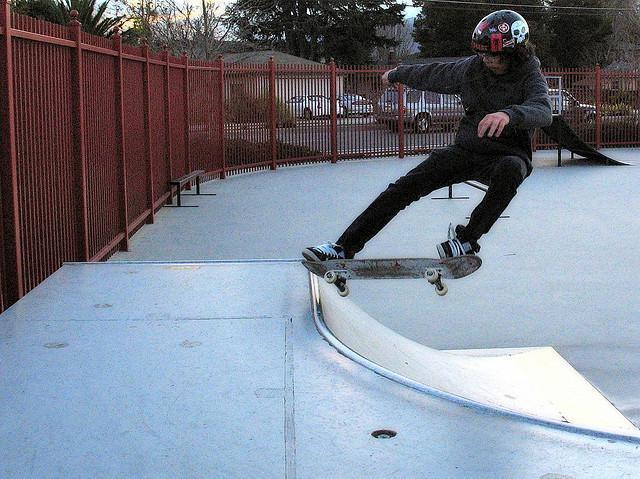How many motor vehicles are pictured?
Give a very brief answer. 4. 